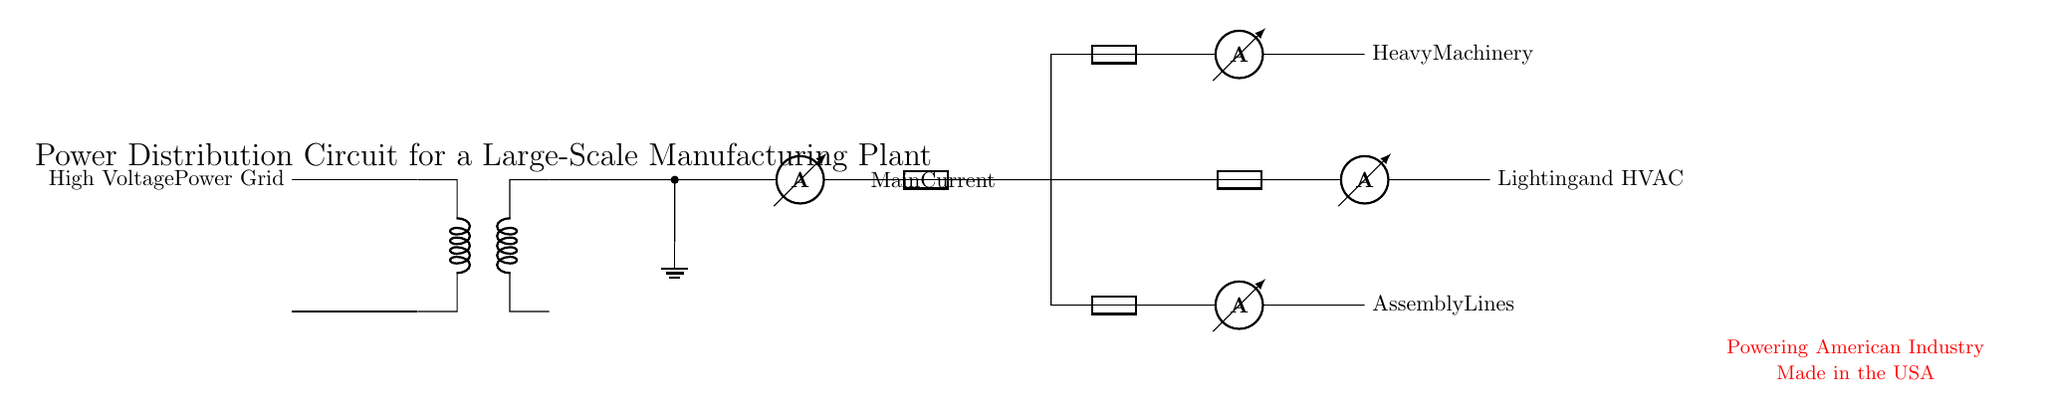What does the high voltage power grid connect to? The high voltage power grid connects to the transformer, which steps down the voltage for distribution in the plant.
Answer: transformer Which component measures the main current? The component that measures the main current is the ammeter located immediately after the main distribution.
Answer: ammeter How many branches are in the power distribution circuit? There are three branches in the circuit: Heavy Machinery, Assembly Lines, and Lighting and HVAC.
Answer: three What is the purpose of the fuse in each branch? The fuse serves as a protective device that prevents overcurrent by breaking the circuit when the current exceeds a safe limit.
Answer: protection What does the lighting and HVAC branch power? The lighting and HVAC branch powers the lighting system and the heating, ventilation, and air conditioning systems in the plant.
Answer: lighting and HVAC Which components are shown in the heavy machinery branch? The components in the heavy machinery branch include a fuse and an ammeter, indicating protection and measurement of current in that section.
Answer: fuse, ammeter What does the patriotic message at the bottom signify? The patriotic message signifies a commitment to American industry and emphasizes the pride in manufacturing equipment and products in the USA.
Answer: Made in the USA 